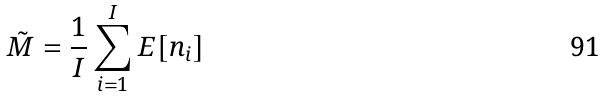Convert formula to latex. <formula><loc_0><loc_0><loc_500><loc_500>\tilde { M } = \frac { 1 } { I } \sum _ { i = 1 } ^ { I } E [ n _ { i } ]</formula> 